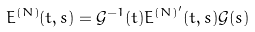Convert formula to latex. <formula><loc_0><loc_0><loc_500><loc_500>E ^ { ( N ) } ( t , s ) = \mathcal { G } ^ { - 1 } ( t ) E ^ { ( N ) ^ { \prime } } ( t , s ) \mathcal { G } ( s )</formula> 